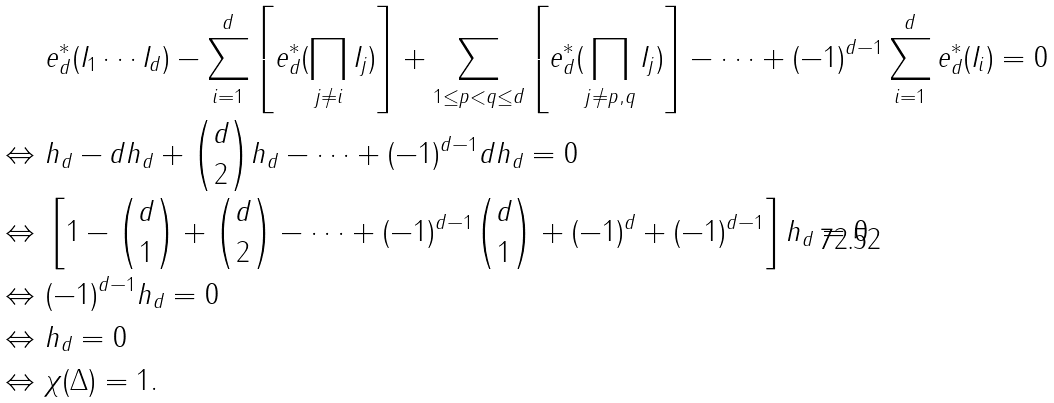<formula> <loc_0><loc_0><loc_500><loc_500>& \ e ^ { * } _ { d } ( I _ { 1 } \cdots I _ { d } ) - \sum _ { i = 1 } ^ { d } \left [ e ^ { * } _ { d } ( \prod _ { j \not = i } I _ { j } ) \right ] + \sum _ { 1 \leq p < q \leq d } \left [ e ^ { * } _ { d } ( \prod _ { j \not = p , q } I _ { j } ) \right ] - \cdots + ( - 1 ) ^ { d - 1 } \sum _ { i = 1 } ^ { d } e ^ { * } _ { d } ( I _ { i } ) = 0 \\ \Leftrightarrow & \ h _ { d } - d h _ { d } + { d \choose 2 } h _ { d } - \cdots + ( - 1 ) ^ { d - 1 } d h _ { d } = 0 \\ \Leftrightarrow & \ \left [ 1 - { d \choose 1 } + { d \choose 2 } - \cdots + ( - 1 ) ^ { d - 1 } { d \choose 1 } + ( - 1 ) ^ { d } + ( - 1 ) ^ { d - 1 } \right ] h _ { d } = 0 \\ \Leftrightarrow & \ ( - 1 ) ^ { d - 1 } h _ { d } = 0 \\ \Leftrightarrow & \ h _ { d } = 0 \\ \Leftrightarrow & \ \chi ( \Delta ) = 1 .</formula> 